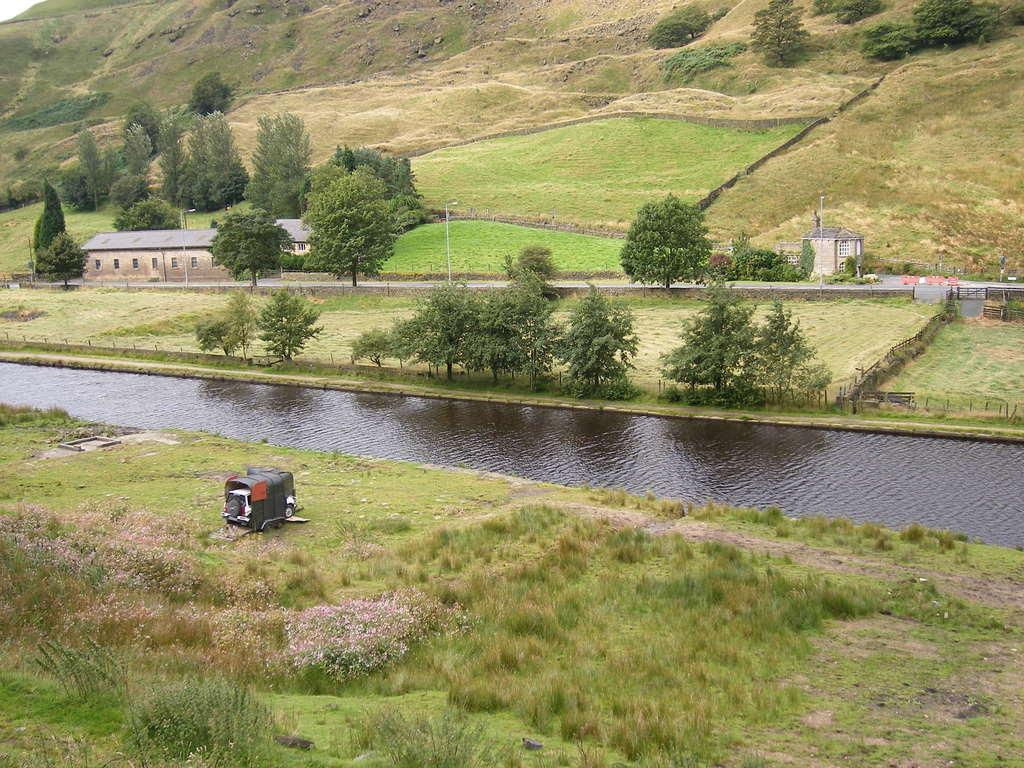What is the main feature in the center of the image? There is a lake in the center of the image. What type of vegetation can be seen in the image? There is grass and plants visible in the image. Can you describe the unspecified object in the image? Unfortunately, the facts provided do not specify the nature of the unspecified object. What can be seen in the background of the image? There are trees, buildings, poles, and a walkway visible in the background of the image. What type of market can be seen in the image? There is no market present in the image; it features a lake, grass, plants, and various background elements. What knowledge can be gained from the image? The image provides visual information about the lake, vegetation, and background elements, but it does not convey any specific knowledge or facts beyond what is visible. 